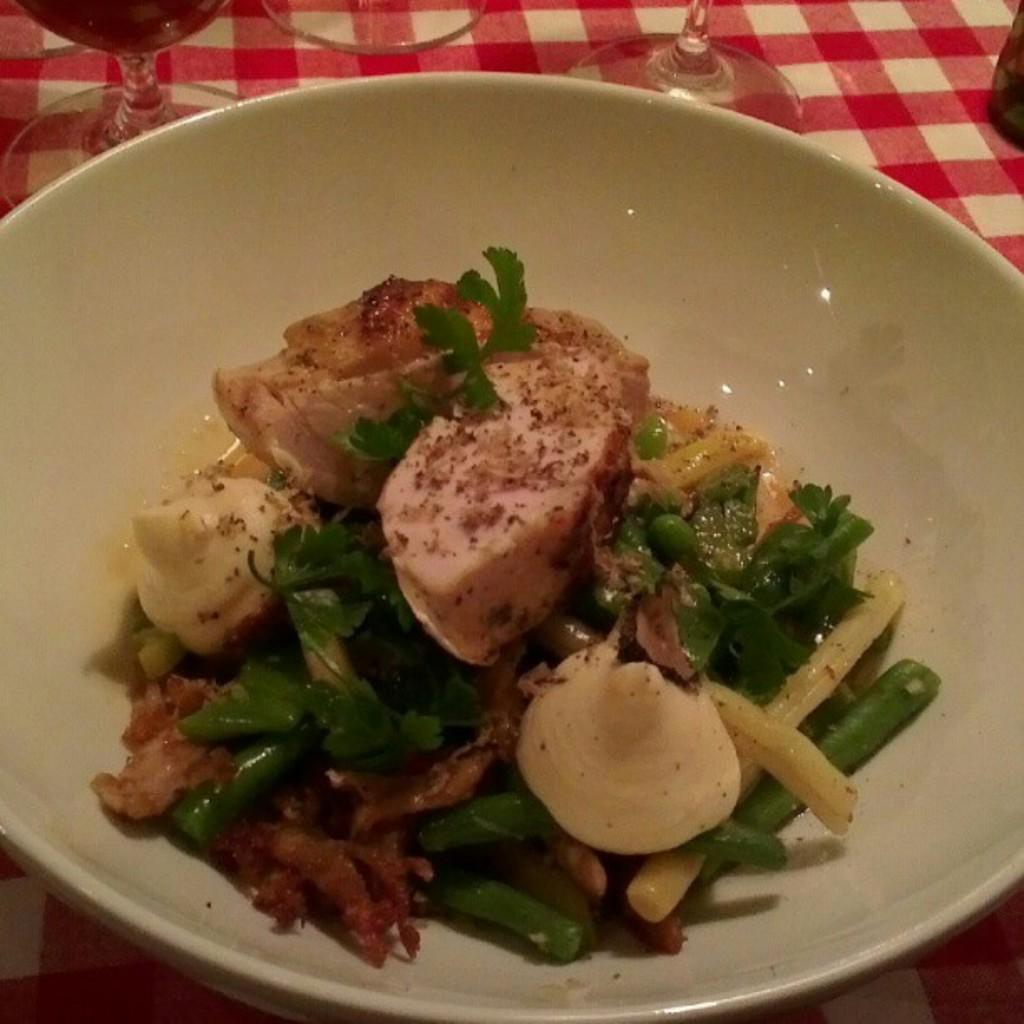In one or two sentences, can you explain what this image depicts? In this picture we can see a bowl with food in it and glasses on a cloth. 